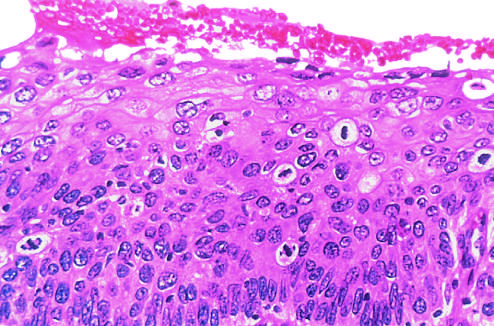does the injurious stimulus show failure of normal differentiation, marked nuclear and cellular pleomorphism, and numerous mitotic figures extending toward the surface?
Answer the question using a single word or phrase. No 